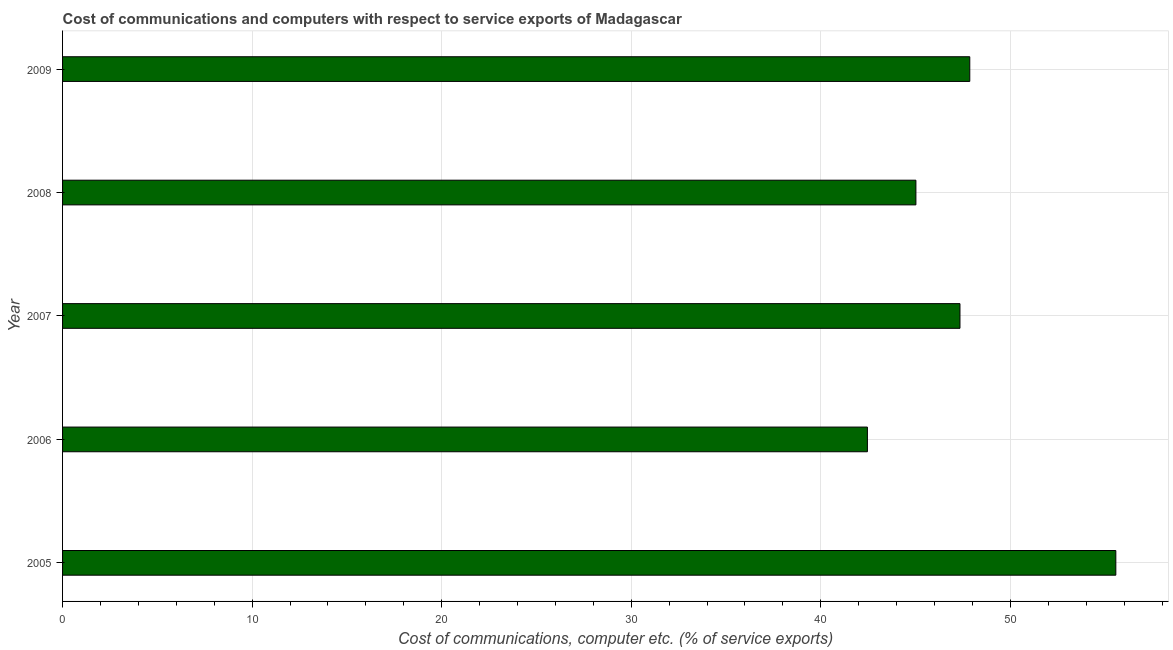Does the graph contain any zero values?
Offer a terse response. No. What is the title of the graph?
Give a very brief answer. Cost of communications and computers with respect to service exports of Madagascar. What is the label or title of the X-axis?
Your answer should be very brief. Cost of communications, computer etc. (% of service exports). What is the cost of communications and computer in 2006?
Provide a short and direct response. 42.46. Across all years, what is the maximum cost of communications and computer?
Your answer should be very brief. 55.56. Across all years, what is the minimum cost of communications and computer?
Give a very brief answer. 42.46. What is the sum of the cost of communications and computer?
Offer a very short reply. 238.24. What is the difference between the cost of communications and computer in 2006 and 2008?
Ensure brevity in your answer.  -2.56. What is the average cost of communications and computer per year?
Keep it short and to the point. 47.65. What is the median cost of communications and computer?
Provide a succinct answer. 47.34. Do a majority of the years between 2008 and 2006 (inclusive) have cost of communications and computer greater than 54 %?
Provide a short and direct response. Yes. What is the ratio of the cost of communications and computer in 2007 to that in 2008?
Make the answer very short. 1.05. Is the difference between the cost of communications and computer in 2006 and 2007 greater than the difference between any two years?
Your response must be concise. No. What is the difference between the highest and the second highest cost of communications and computer?
Your response must be concise. 7.71. What is the difference between two consecutive major ticks on the X-axis?
Your answer should be compact. 10. What is the Cost of communications, computer etc. (% of service exports) in 2005?
Your answer should be very brief. 55.56. What is the Cost of communications, computer etc. (% of service exports) in 2006?
Provide a short and direct response. 42.46. What is the Cost of communications, computer etc. (% of service exports) in 2007?
Give a very brief answer. 47.34. What is the Cost of communications, computer etc. (% of service exports) in 2008?
Your answer should be very brief. 45.02. What is the Cost of communications, computer etc. (% of service exports) in 2009?
Keep it short and to the point. 47.86. What is the difference between the Cost of communications, computer etc. (% of service exports) in 2005 and 2006?
Keep it short and to the point. 13.1. What is the difference between the Cost of communications, computer etc. (% of service exports) in 2005 and 2007?
Your answer should be very brief. 8.22. What is the difference between the Cost of communications, computer etc. (% of service exports) in 2005 and 2008?
Make the answer very short. 10.55. What is the difference between the Cost of communications, computer etc. (% of service exports) in 2005 and 2009?
Keep it short and to the point. 7.7. What is the difference between the Cost of communications, computer etc. (% of service exports) in 2006 and 2007?
Keep it short and to the point. -4.88. What is the difference between the Cost of communications, computer etc. (% of service exports) in 2006 and 2008?
Provide a short and direct response. -2.56. What is the difference between the Cost of communications, computer etc. (% of service exports) in 2006 and 2009?
Your response must be concise. -5.4. What is the difference between the Cost of communications, computer etc. (% of service exports) in 2007 and 2008?
Offer a terse response. 2.32. What is the difference between the Cost of communications, computer etc. (% of service exports) in 2007 and 2009?
Your answer should be compact. -0.52. What is the difference between the Cost of communications, computer etc. (% of service exports) in 2008 and 2009?
Keep it short and to the point. -2.84. What is the ratio of the Cost of communications, computer etc. (% of service exports) in 2005 to that in 2006?
Keep it short and to the point. 1.31. What is the ratio of the Cost of communications, computer etc. (% of service exports) in 2005 to that in 2007?
Give a very brief answer. 1.17. What is the ratio of the Cost of communications, computer etc. (% of service exports) in 2005 to that in 2008?
Offer a very short reply. 1.23. What is the ratio of the Cost of communications, computer etc. (% of service exports) in 2005 to that in 2009?
Your response must be concise. 1.16. What is the ratio of the Cost of communications, computer etc. (% of service exports) in 2006 to that in 2007?
Keep it short and to the point. 0.9. What is the ratio of the Cost of communications, computer etc. (% of service exports) in 2006 to that in 2008?
Make the answer very short. 0.94. What is the ratio of the Cost of communications, computer etc. (% of service exports) in 2006 to that in 2009?
Your response must be concise. 0.89. What is the ratio of the Cost of communications, computer etc. (% of service exports) in 2007 to that in 2008?
Provide a succinct answer. 1.05. What is the ratio of the Cost of communications, computer etc. (% of service exports) in 2007 to that in 2009?
Offer a very short reply. 0.99. What is the ratio of the Cost of communications, computer etc. (% of service exports) in 2008 to that in 2009?
Give a very brief answer. 0.94. 